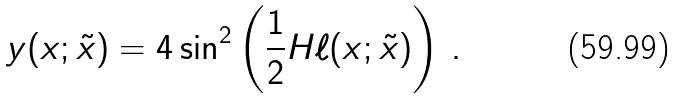<formula> <loc_0><loc_0><loc_500><loc_500>y ( x ; \tilde { x } ) = 4 \sin ^ { 2 } \left ( \frac { 1 } { 2 } H \ell ( x ; \tilde { x } ) \right ) \, .</formula> 